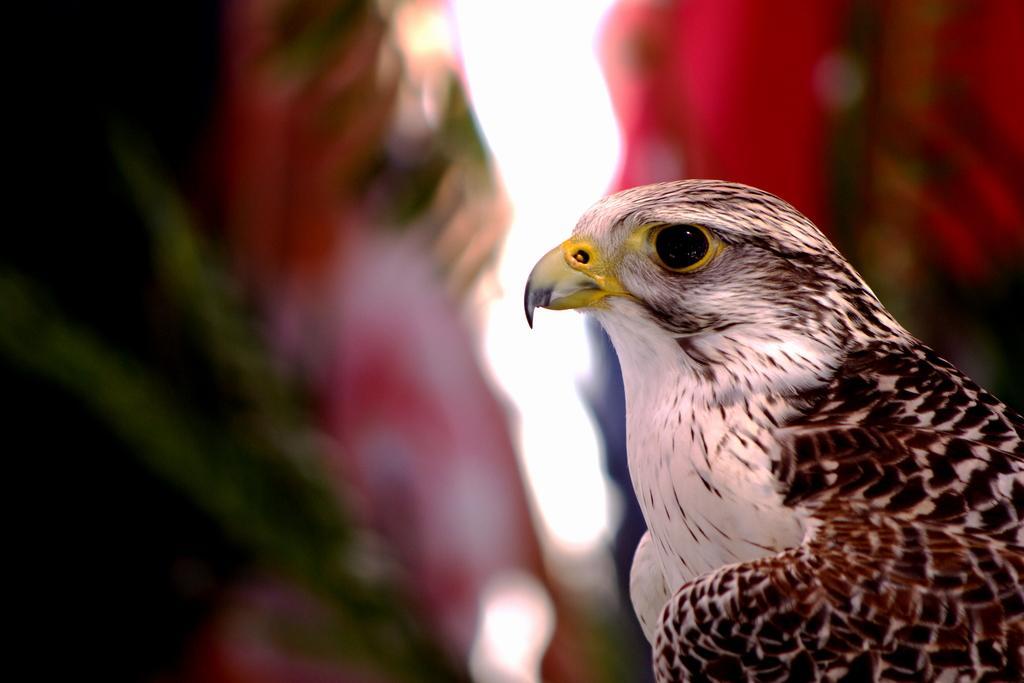In one or two sentences, can you explain what this image depicts? In this image there is an eagle in the middle. 